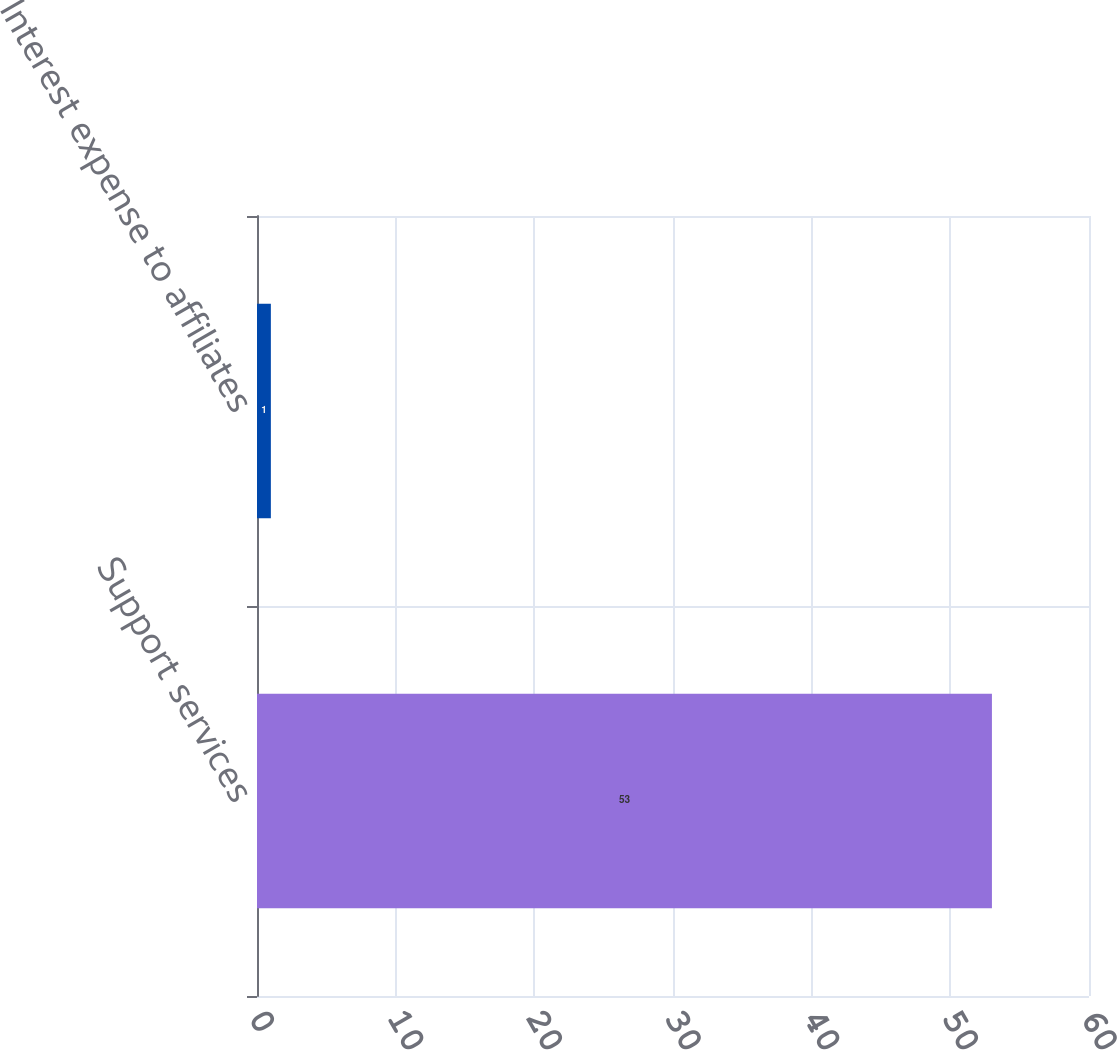<chart> <loc_0><loc_0><loc_500><loc_500><bar_chart><fcel>Support services<fcel>Interest expense to affiliates<nl><fcel>53<fcel>1<nl></chart> 